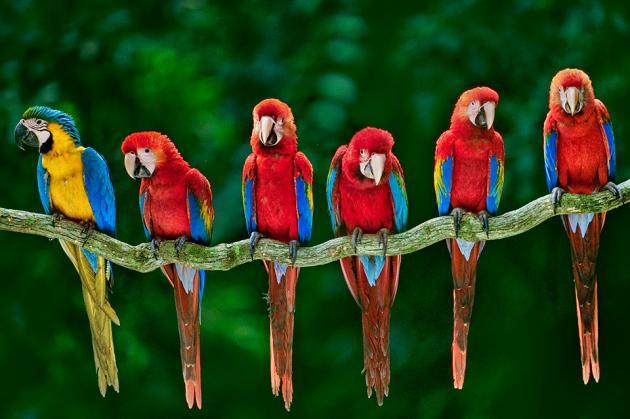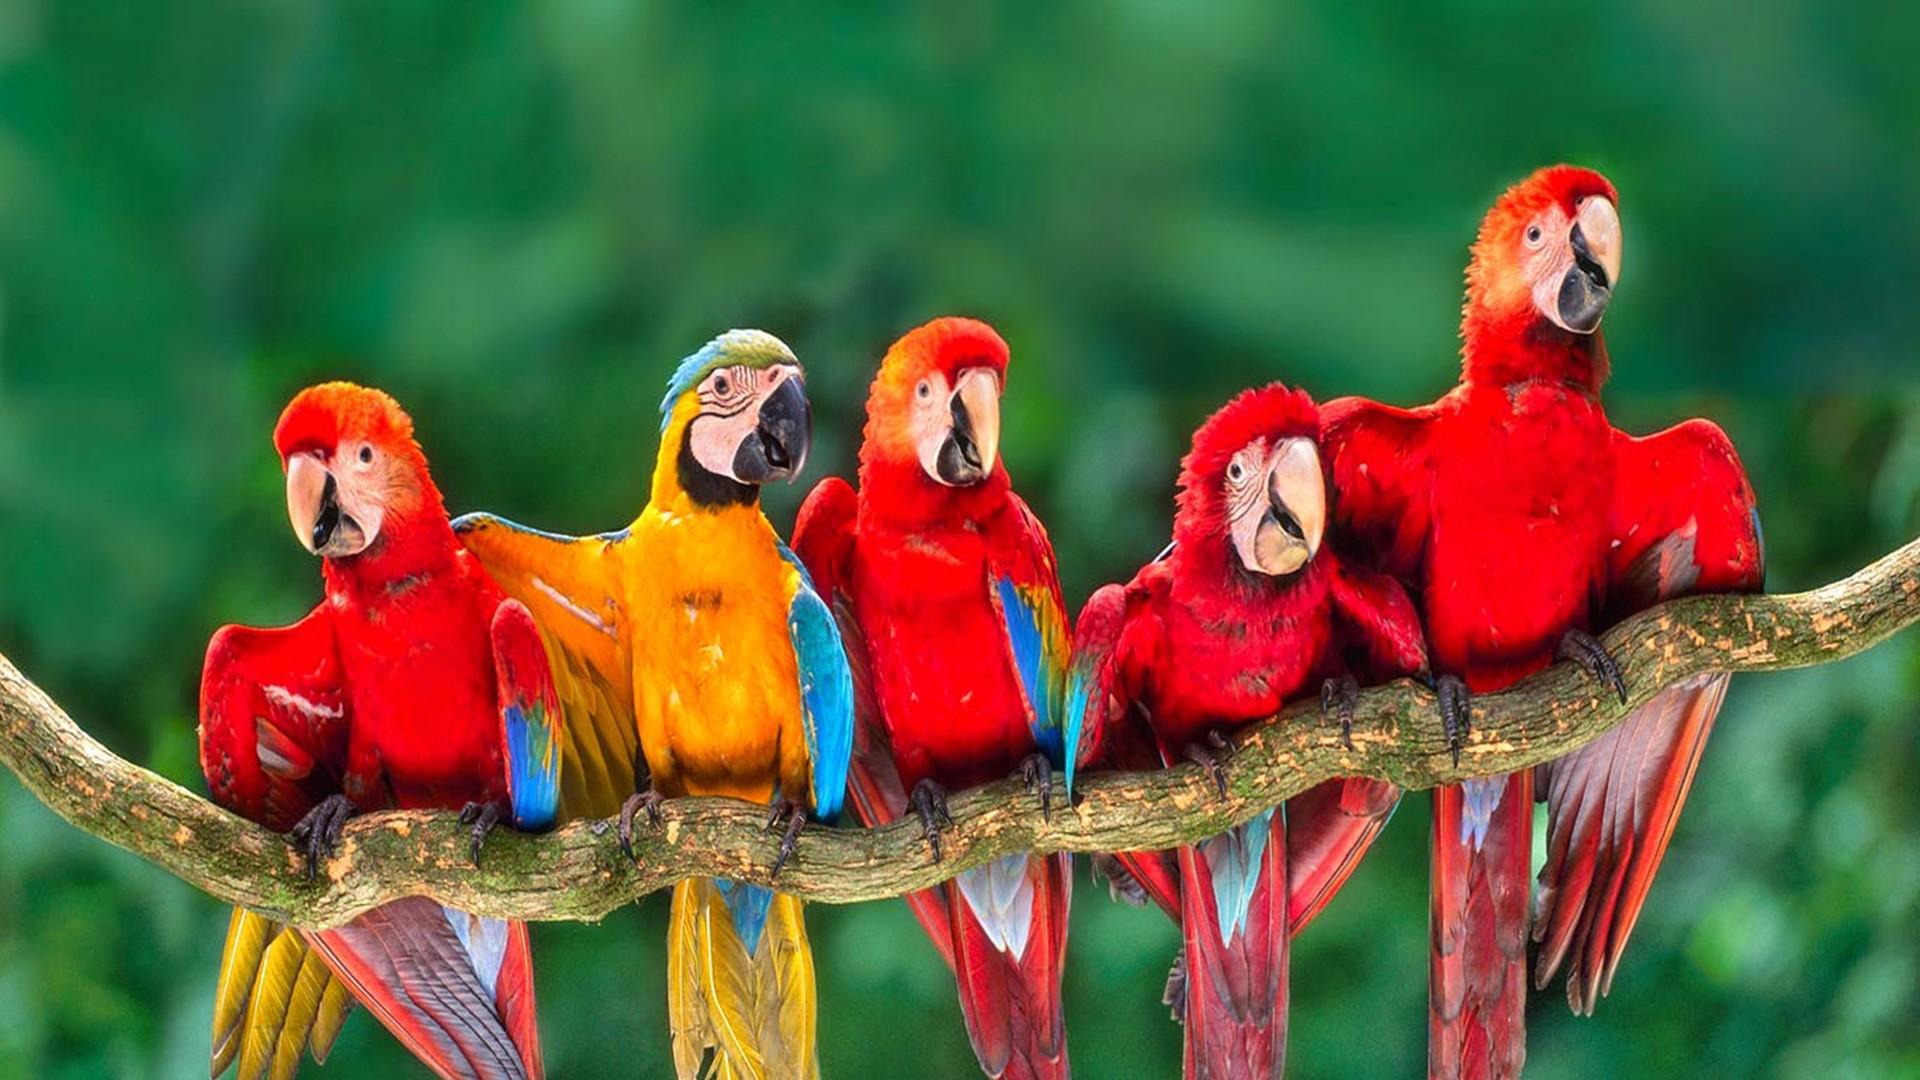The first image is the image on the left, the second image is the image on the right. Assess this claim about the two images: "One of the images contains exactly five birds.". Correct or not? Answer yes or no. Yes. 